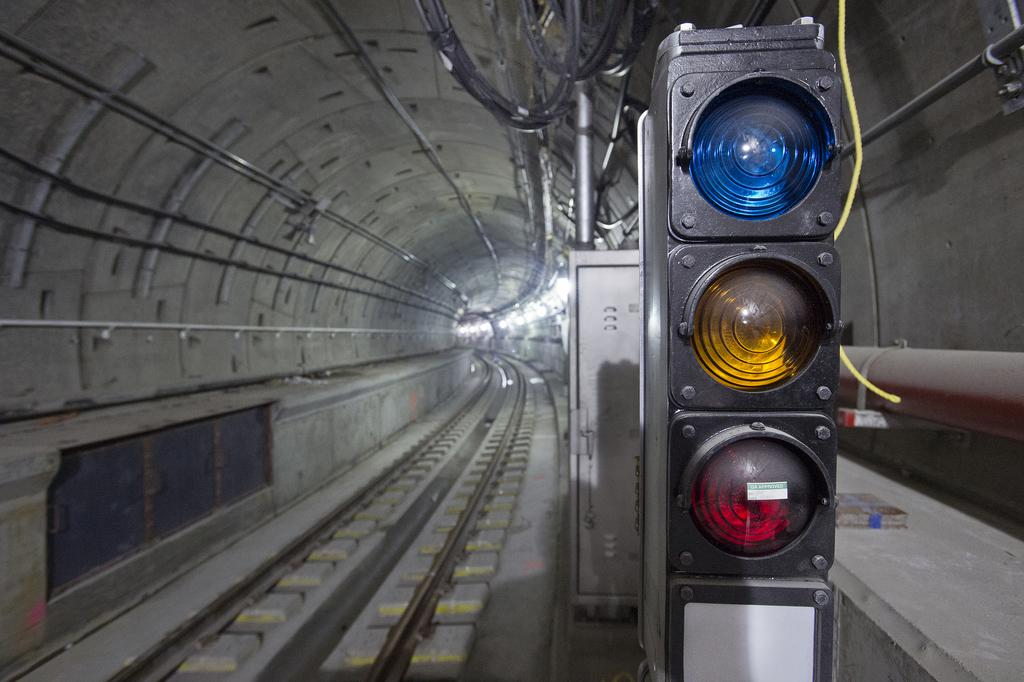What type of transportation system is depicted in the image? The image shows a subway system, specifically a track inside a subway. What can be seen running alongside the track? There are wires and pipes visible in the image. What might be used for carrying or storing items in the image? There is a container present in the image. What safety feature is present at the intersection of the tracks? The traffic lights are present in the image. What type of verse can be heard recited by the sponge in the image? There is no sponge present in the image, and therefore no verse can be heard. 